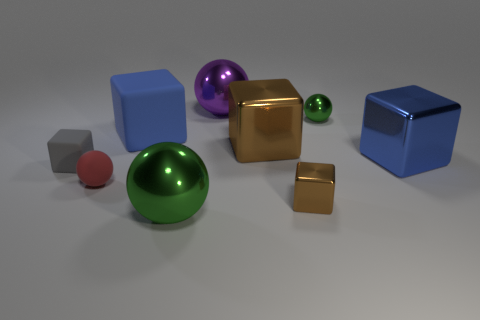Is there anything else of the same color as the small metal block?
Your answer should be compact. Yes. Are there any big brown blocks on the left side of the tiny brown cube?
Provide a succinct answer. Yes. What size is the green ball behind the large object in front of the blue metal block?
Ensure brevity in your answer.  Small. Are there an equal number of small gray matte blocks that are in front of the big green metallic thing and large blue rubber things left of the tiny gray rubber cube?
Ensure brevity in your answer.  Yes. Are there any blocks on the left side of the big cube that is to the right of the tiny brown metal thing?
Ensure brevity in your answer.  Yes. There is a green object that is on the right side of the green thing in front of the tiny green shiny sphere; what number of big purple metal things are behind it?
Make the answer very short. 1. Are there fewer large blue metal blocks than small purple things?
Provide a short and direct response. No. Is the shape of the small metallic object in front of the small gray thing the same as the green thing behind the large blue rubber object?
Your response must be concise. No. The matte ball is what color?
Offer a very short reply. Red. How many metal things are either brown things or tiny spheres?
Your answer should be compact. 3. 